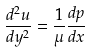Convert formula to latex. <formula><loc_0><loc_0><loc_500><loc_500>\frac { d ^ { 2 } u } { d y ^ { 2 } } = \frac { 1 } { \mu } \frac { d p } { d x }</formula> 